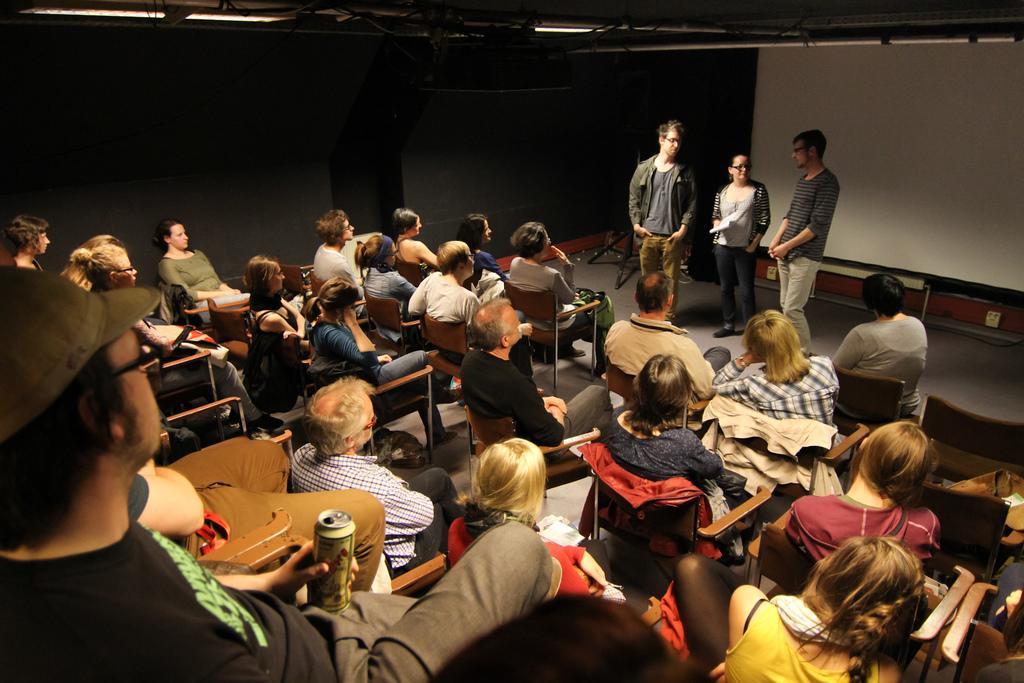Please provide a concise description of this image. In this image I can see the group of people sitting on the chairs. These people are wearing the different color dresses and one person is holding the tin. In-front of these people I can see three people. There are the lights in the top. 